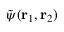<formula> <loc_0><loc_0><loc_500><loc_500>\tilde { \psi } ( r _ { 1 } , r _ { 2 } )</formula> 